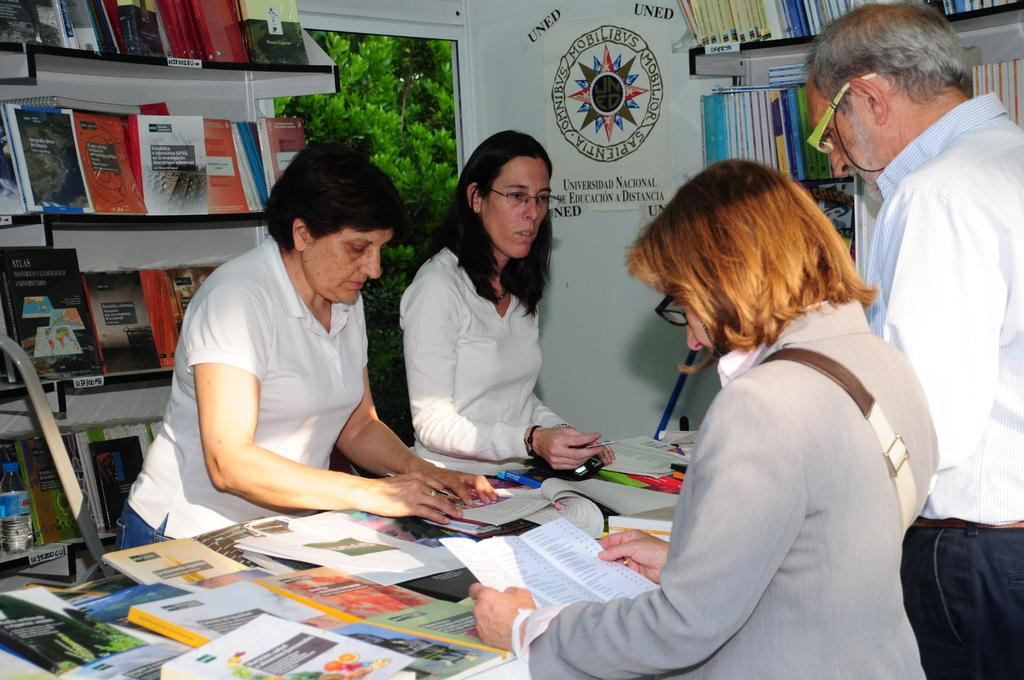How many ladies are in the picture?
Offer a terse response. Answering does not require reading text in the image. 